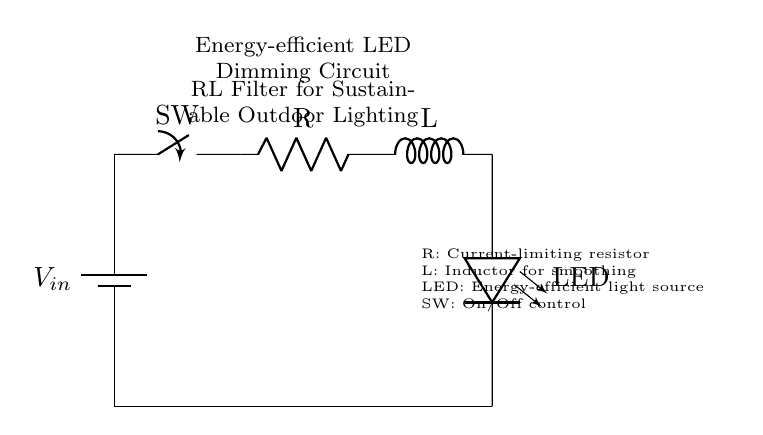What is the purpose of the resistor in this circuit? The resistor is labeled as R in the circuit, and it serves as a current-limiting component to protect the LED from excessive current. In a typical LED circuit, too much current can damage the LED, so the resistor ensures that the current flowing through the LED remains within safe limits.
Answer: Current-limiting What type of component is represented by L in the diagram? L in the diagram represents an inductor, which is a passive electrical component that stores energy in a magnetic field when electric current flows through it. Inductors are typically used to smooth out variations in current and both stabilize and filter signals.
Answer: Inductor How many components are visible in the circuit? The components visible in the circuit are the power supply, switch, resistor, inductor, LED, and ground. Counting these, there are a total of five distinct components represented in the circuit diagram.
Answer: Five What does the LED represent in terms of sustainability? The LED represents an energy-efficient light source, which is significant for sustainable outdoor lighting due to its low power consumption and long lifespan compared to traditional lighting options. This characteristic aligns with environmental goals of reducing energy consumption and minimizing waste.
Answer: Energy-efficient light source How does the inductor affect the LED brightness in this circuit? The inductor allows for a gradual change in current, which leads to a smoother flow of electricity to the LED. This smoothing effect reduces flickering and can lower the overall brightness of the LED, achieving a dimming effect while being energy-efficient. The inductor's storage of energy also helps maintain LED operation during momentary interruptions.
Answer: Smoothens current flow 